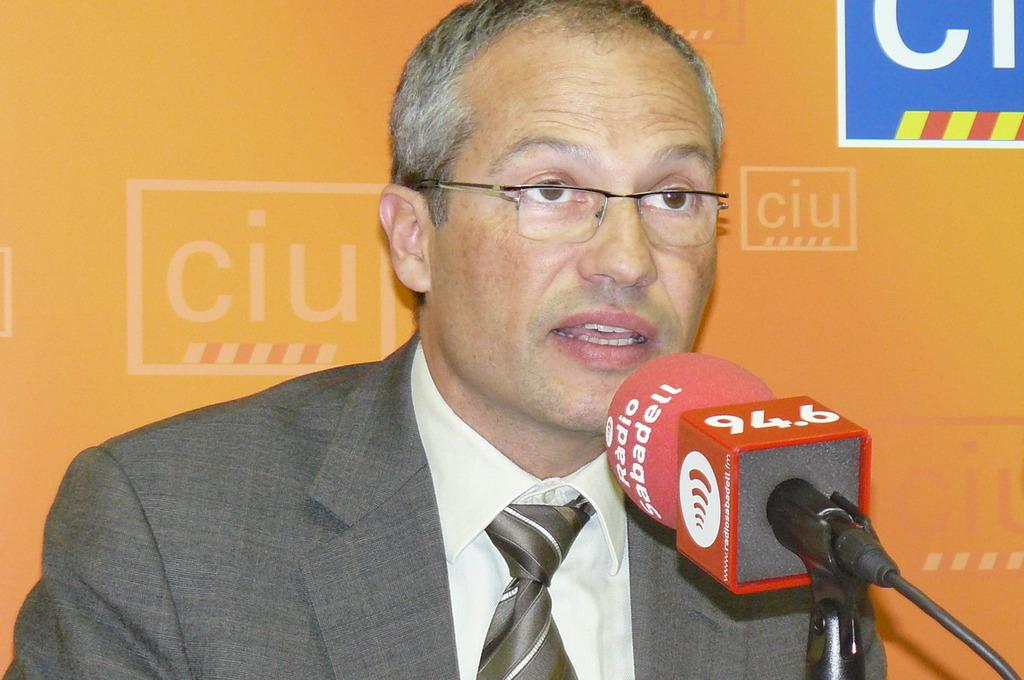Who is the main subject in the image? There is a man in the image. What is the man wearing? The man is wearing spectacles. What object is in front of the man? There is a microphone in front of the man. What can be seen in the background of the image? There is a board with words in the background of the image. How many fingers does the man have on his left hand in the image? The image does not show the man's fingers, so it is not possible to determine the number of fingers on his left hand. 